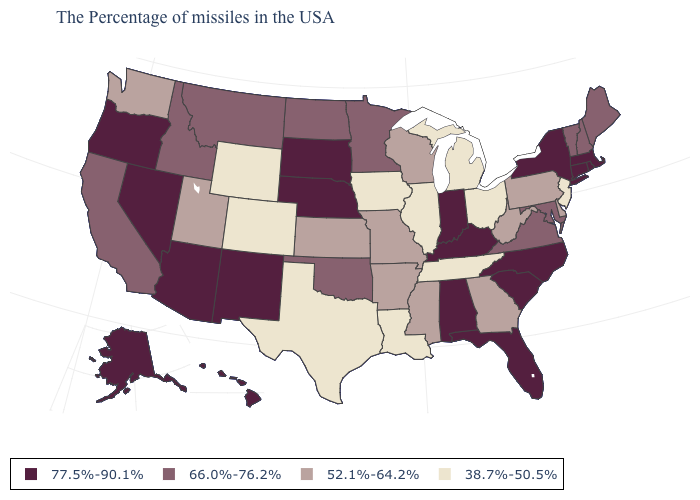Name the states that have a value in the range 38.7%-50.5%?
Give a very brief answer. New Jersey, Ohio, Michigan, Tennessee, Illinois, Louisiana, Iowa, Texas, Wyoming, Colorado. What is the value of Montana?
Quick response, please. 66.0%-76.2%. What is the value of Oregon?
Write a very short answer. 77.5%-90.1%. Which states have the lowest value in the South?
Write a very short answer. Tennessee, Louisiana, Texas. Does Louisiana have the lowest value in the USA?
Write a very short answer. Yes. Does the map have missing data?
Keep it brief. No. Does North Dakota have the lowest value in the USA?
Quick response, please. No. Name the states that have a value in the range 77.5%-90.1%?
Write a very short answer. Massachusetts, Rhode Island, Connecticut, New York, North Carolina, South Carolina, Florida, Kentucky, Indiana, Alabama, Nebraska, South Dakota, New Mexico, Arizona, Nevada, Oregon, Alaska, Hawaii. What is the value of Mississippi?
Answer briefly. 52.1%-64.2%. What is the lowest value in states that border Arkansas?
Short answer required. 38.7%-50.5%. What is the value of Pennsylvania?
Give a very brief answer. 52.1%-64.2%. Which states hav the highest value in the Northeast?
Concise answer only. Massachusetts, Rhode Island, Connecticut, New York. What is the value of Arizona?
Keep it brief. 77.5%-90.1%. Name the states that have a value in the range 52.1%-64.2%?
Short answer required. Delaware, Pennsylvania, West Virginia, Georgia, Wisconsin, Mississippi, Missouri, Arkansas, Kansas, Utah, Washington. What is the lowest value in the USA?
Quick response, please. 38.7%-50.5%. 